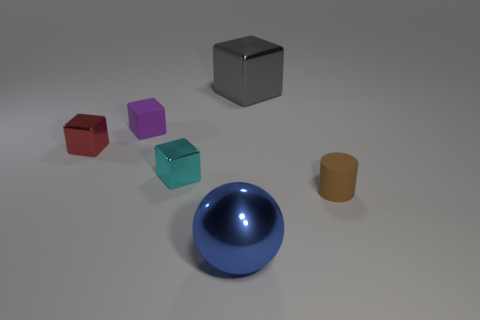Add 2 cylinders. How many objects exist? 8 Subtract all balls. How many objects are left? 5 Add 4 tiny red blocks. How many tiny red blocks are left? 5 Add 1 gray blocks. How many gray blocks exist? 2 Subtract 0 cyan balls. How many objects are left? 6 Subtract all tiny metallic cubes. Subtract all purple matte things. How many objects are left? 3 